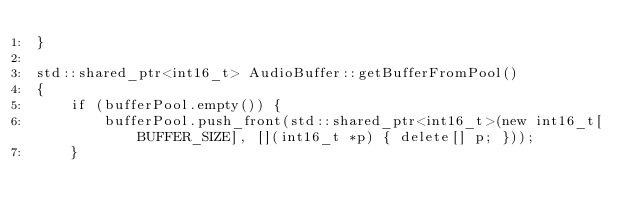Convert code to text. <code><loc_0><loc_0><loc_500><loc_500><_C++_>}

std::shared_ptr<int16_t> AudioBuffer::getBufferFromPool()
{
	if (bufferPool.empty()) {
		bufferPool.push_front(std::shared_ptr<int16_t>(new int16_t[BUFFER_SIZE], [](int16_t *p) { delete[] p; }));
	}
</code> 